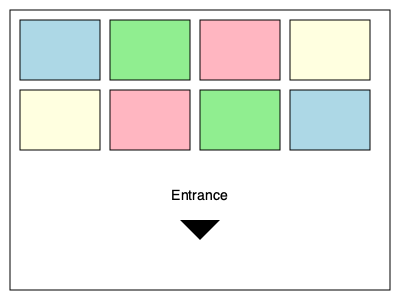As an entrepreneur planning a trade show, you're tasked with optimizing the booth arrangement to maximize foot traffic and visibility. Given the floor plan above with 8 booths and an entrance at the bottom, which color booth would likely receive the most visitor attention and be ideal for showcasing your best deals? To determine the optimal booth location for showcasing deals and attracting visitors, we need to consider several factors:

1. Proximity to the entrance: Booths closer to the entrance tend to receive more traffic as visitors enter the show.
2. Natural flow of traffic: Visitors typically move in a clockwise or counter-clockwise direction from the entrance.
3. Visibility: Booths that are easily visible from the entrance or main walkways attract more attention.
4. Corner positions: Corner booths often have better visibility and accessibility from multiple directions.

Analyzing the floor plan:

1. The entrance is at the bottom center of the layout.
2. There are two rows of booths, each with four color-coded spaces.
3. The booths closest to the entrance are in the second row.

Considering these factors:

- The yellow booth in the bottom-left corner is closest to the entrance and in a corner position.
- It's likely to be one of the first booths visitors see upon entering.
- Its corner position provides visibility from two directions.
- It aligns with the natural flow of traffic if visitors move counter-clockwise.

Therefore, the yellow booth in the bottom-left corner would likely receive the most visitor attention and be ideal for showcasing your best deals.
Answer: Yellow booth in bottom-left corner 